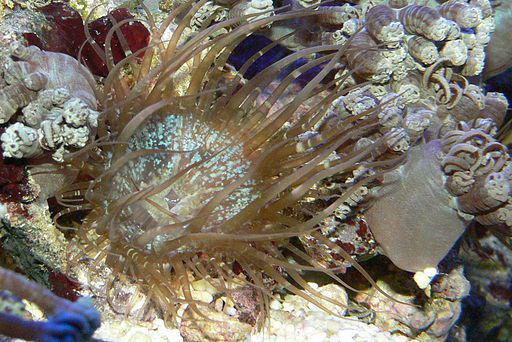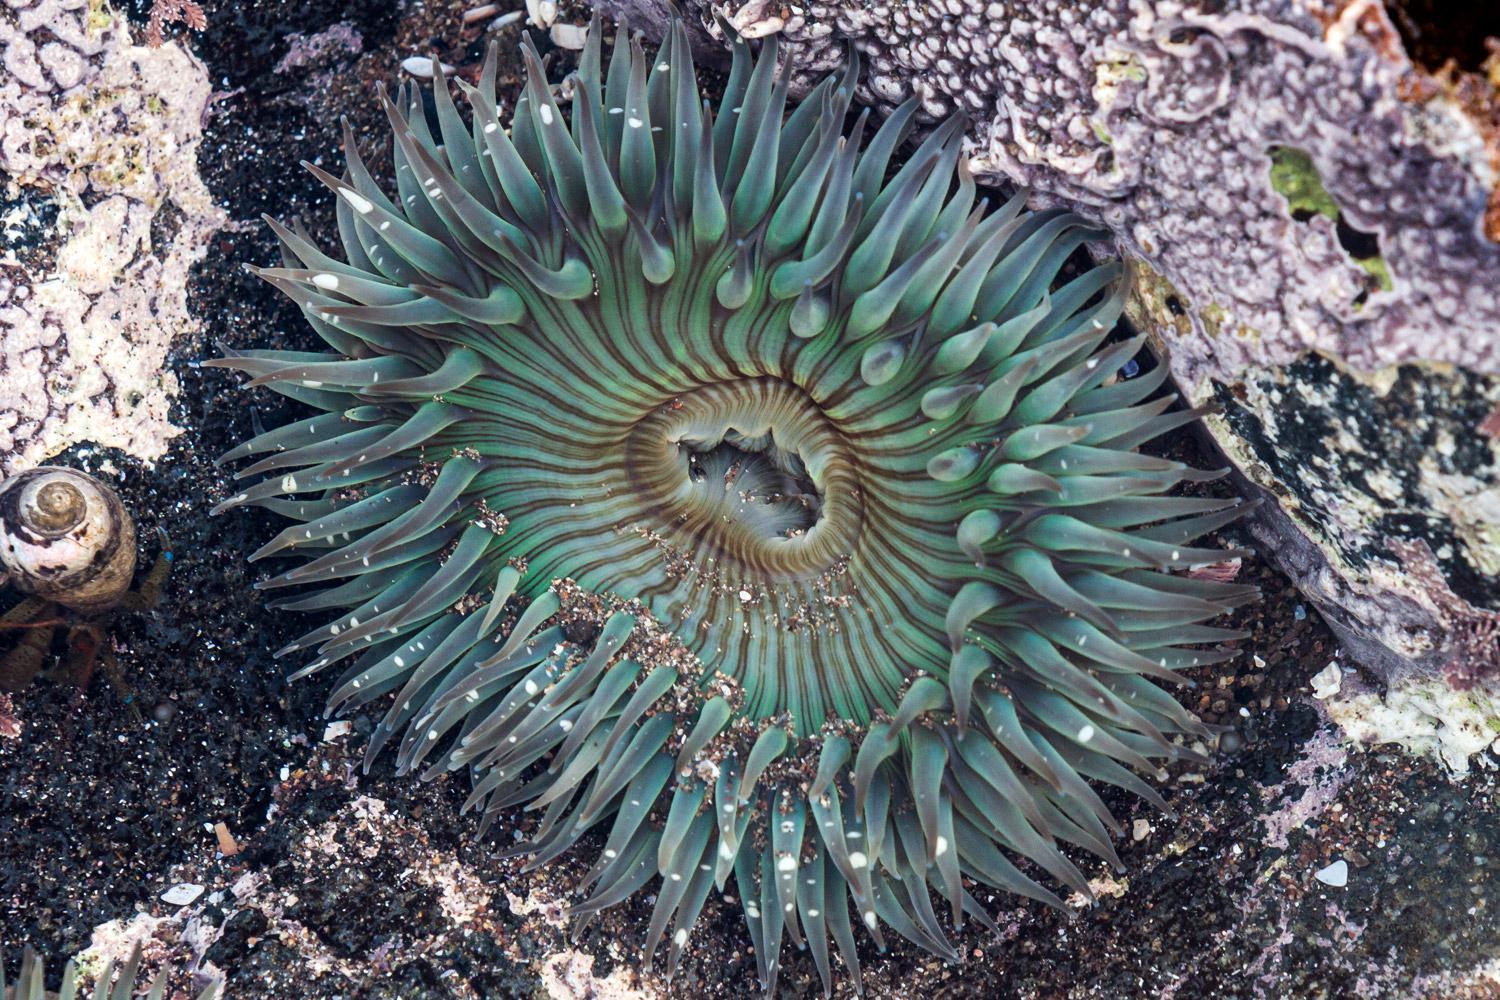The first image is the image on the left, the second image is the image on the right. Given the left and right images, does the statement "Both images contain anemone colored a peachy coral hue." hold true? Answer yes or no. No. 